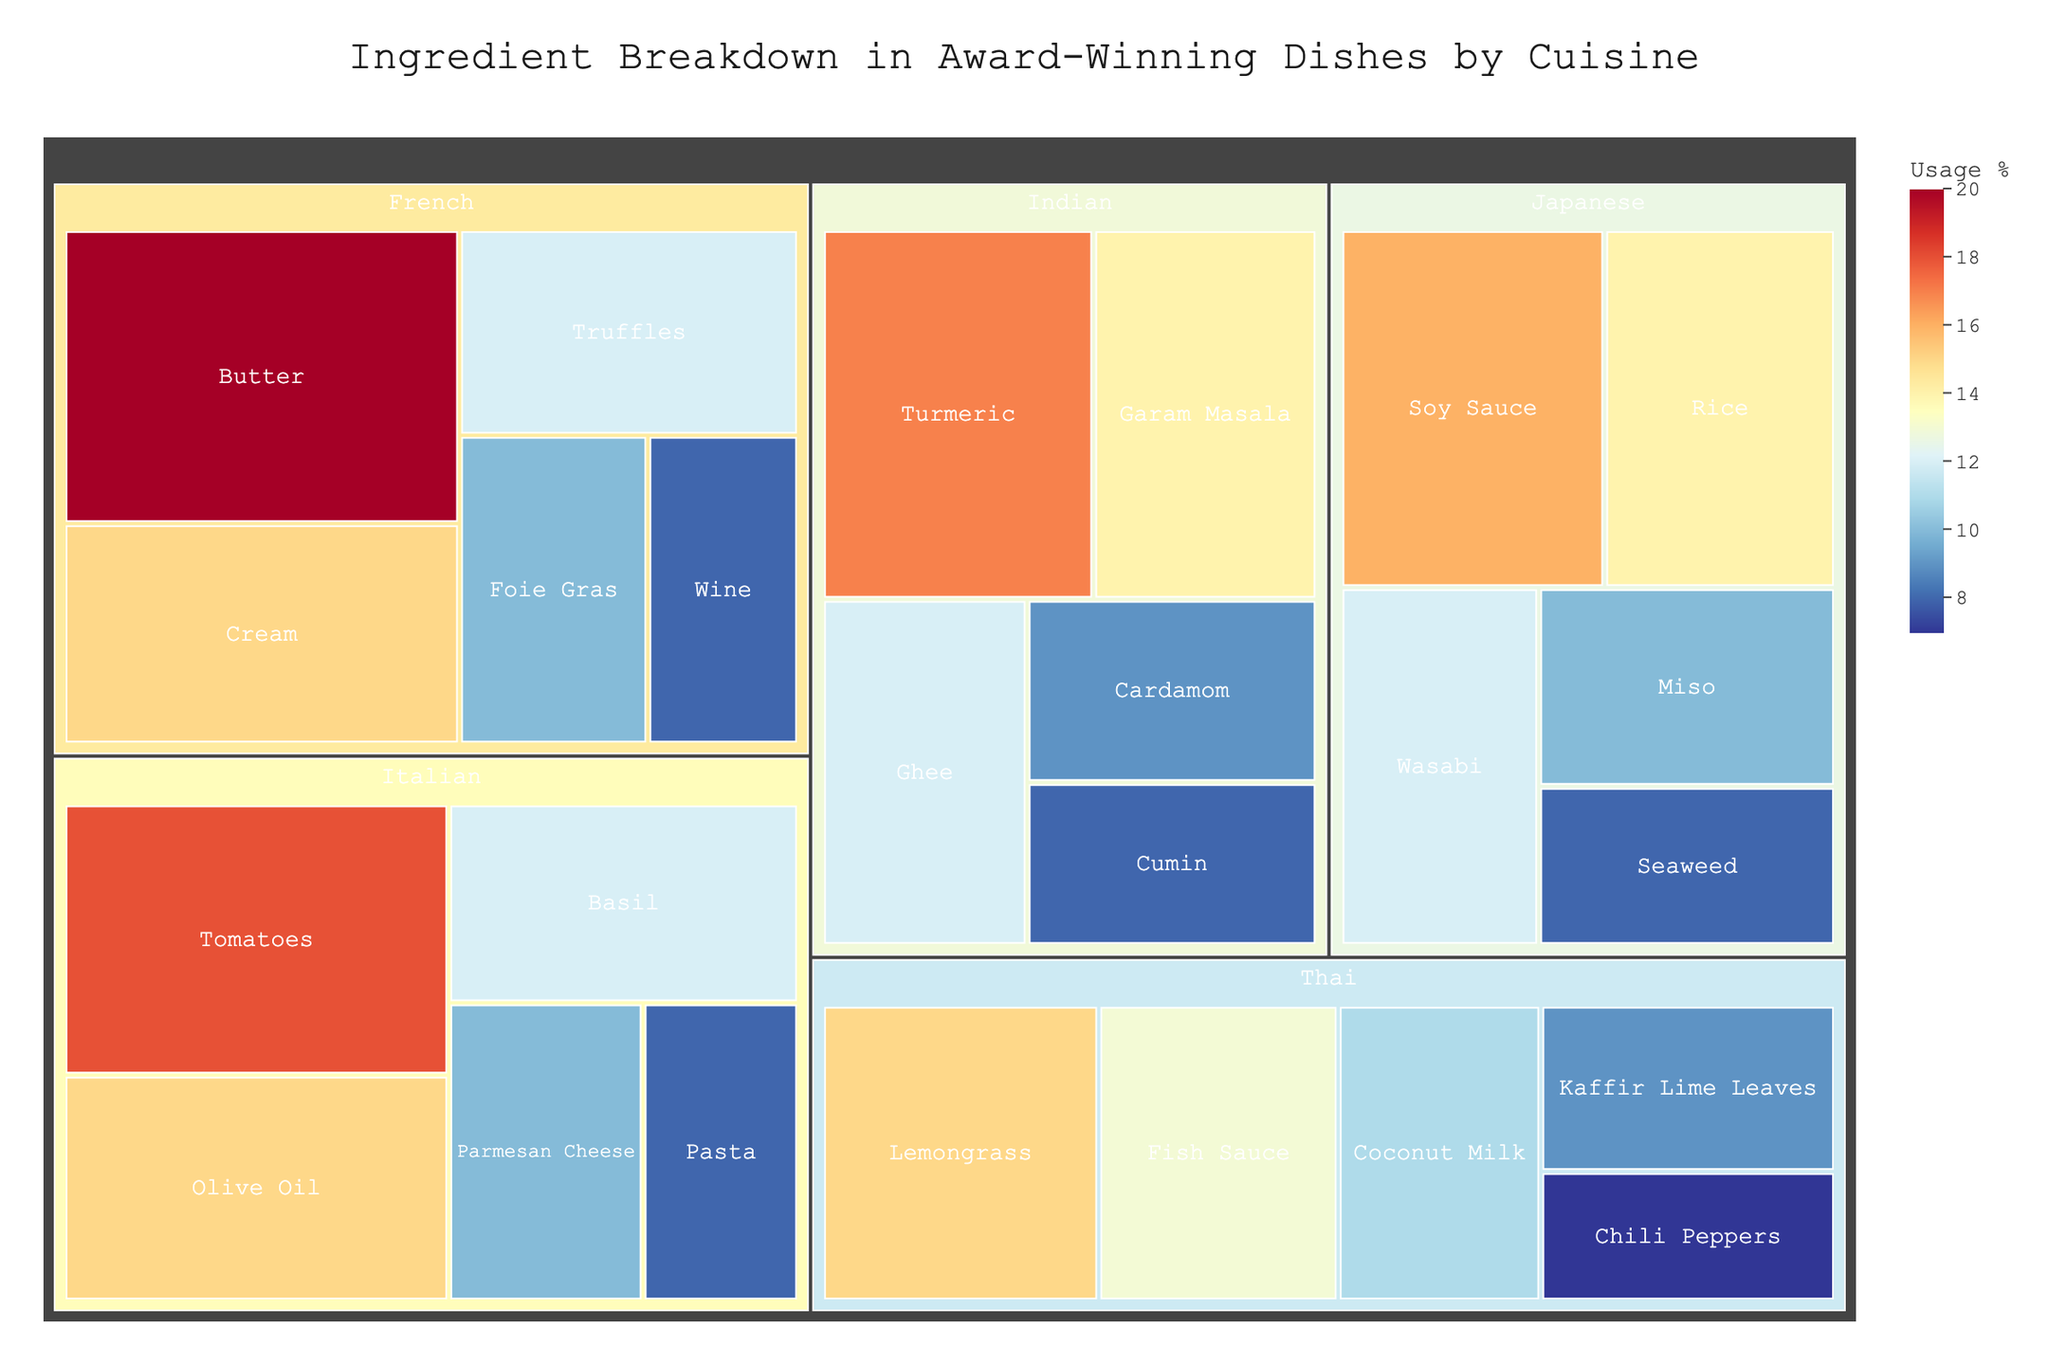What is the most used ingredient in Italian cuisine according to the treemap? Identify the Italian cuisine section and find the largest rectangle, which is labeled with the ingredient and its usage percentage.
Answer: Tomatoes Which Japanese ingredient has the highest usage percentage in the treemap? Locate the Japanese cuisine section and find the largest rectangle within that section. The one with the highest usage percentage is the answer.
Answer: Soy Sauce How does the usage percentage of Butter in French cuisine compare to Olive Oil in Italian cuisine? Compare the rectangles labeled Butter in the French section and Olive Oil in the Italian section. Both percentages are displayed in the labels.
Answer: Butter (20%) is higher than Olive Oil (15%) What is the total usage percentage of the top three ingredients in Indian cuisine? Identify the top three largest rectangles in the Indian cuisine section and sum their usage percentages: Turmeric (17%), Garam Masala (14%), and Ghee (12%). The sum is 17 + 14 + 12 = 43%.
Answer: 43% Which cuisine uses Truffles and what is its usage percentage? Locate the Truffles ingredient on the treemap and check the associated cuisine and its usage percentage.
Answer: French, 12% What is the difference in usage percentage between the highest used ingredient in Thai cuisine and the lowest used ingredient in Japanese cuisine? Identify the highest percentage ingredient in Thai cuisine (Lemongrass, 15%) and the lowest percentage ingredient in Japanese cuisine (Seaweed, 8%). Calculate the difference: 15% - 8% = 7%.
Answer: 7% Which cuisine has the fewest ingredients listed on the treemap and how many are there? Count the ingredients for each cuisine section. The one with the fewest rectangles has the fewest ingredients. Thai cuisine and Indian cuisine both have 5 ingredients, which are the least among the cuisines shown.
Answer: Thai and Indian, 5 What percentage of usage is represented by Miso in Japanese cuisine? Identify the Miso rectangle in the Japanese cuisine section and check its usage percentage label.
Answer: 10% Among the ingredients listed, which one has the lowest usage percentage and in which cuisine does it belong? Scan all rectangles and identify the one with the lowest usage percentage label.
Answer: Chili Peppers, Thai (7%) How many rectangles in total are there in the treemap? Count all the rectangles representing each ingredient across all cuisine sections.
Answer: 25 